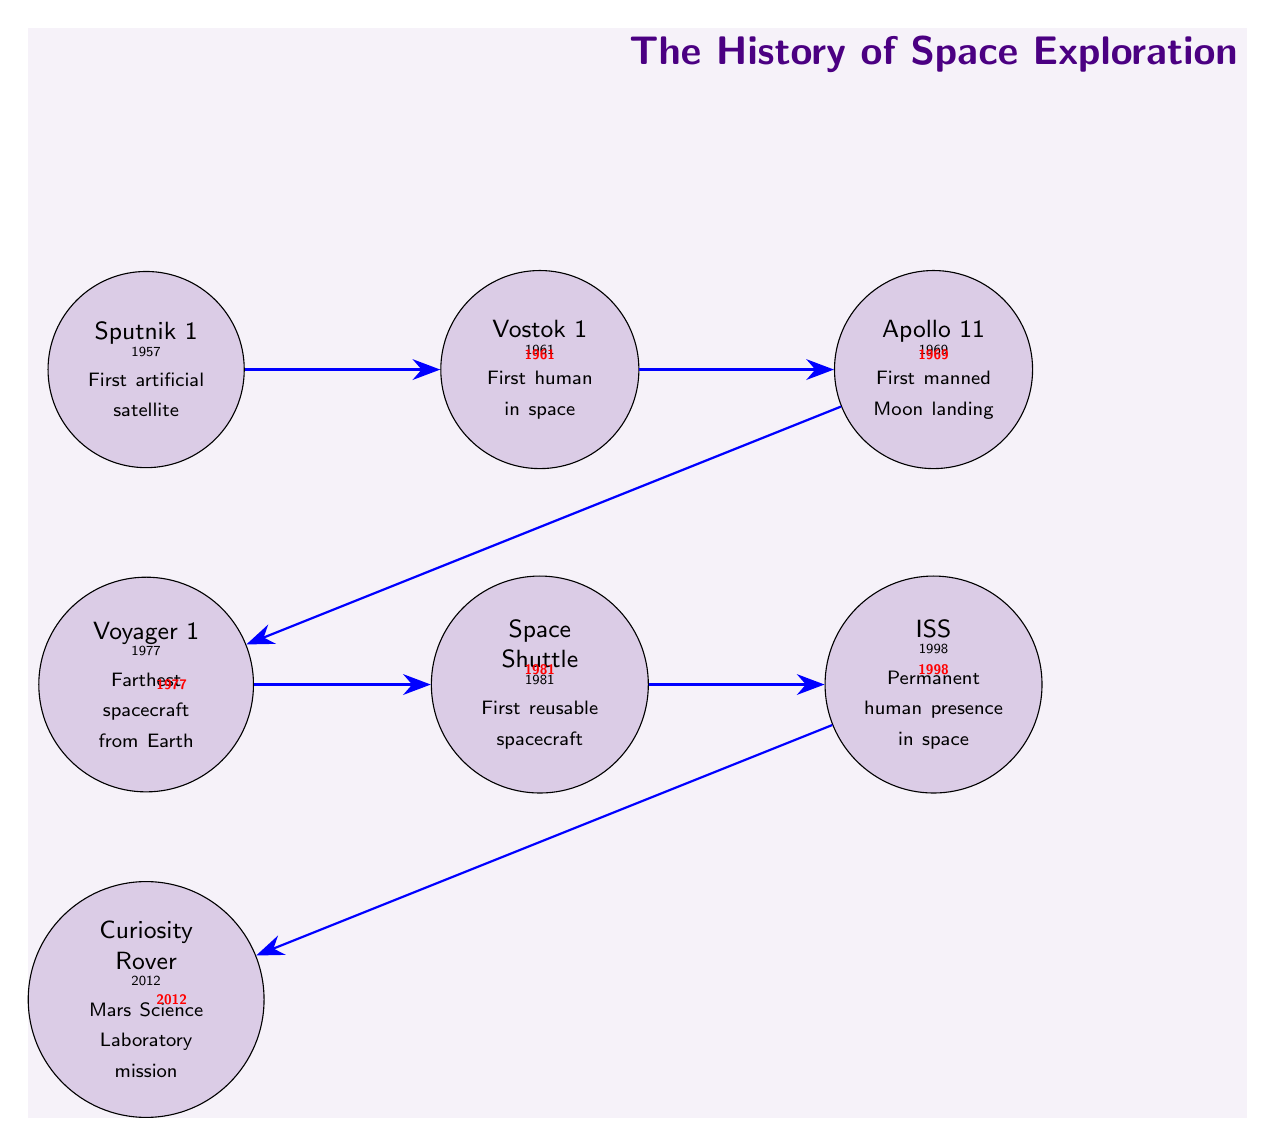What is the year of the first artificial satellite launch? The diagram indicates that the first artificial satellite, Sputnik 1, was launched in the year 1957. This can be directly seen next to the Sputnik node in the diagram.
Answer: 1957 Which event happened after the first human traveled to space? The first human in space, Vostok 1, occurred in 1961, after which Apollo 11, the first manned Moon landing, took place in 1969, as shown by the arrow connecting these two nodes.
Answer: Apollo 11 What is the farthest spacecraft from Earth? The diagram specifies that Voyager 1, launched in 1977, is the farthest spacecraft from Earth, as indicated in the respective node label.
Answer: Voyager 1 How many years were there between the first Moon landing and the launch of the Space Shuttle? The first manned Moon landing (Apollo 11) occurred in 1969 and the Space Shuttle launched in 1981. Thus, the difference is 1981 - 1969 = 12 years, straightforwardly calculated from the years provided in the diagram nodes.
Answer: 12 years What major milestone happened in 1998? According to the diagram, the International Space Station (ISS) was established in 1998, as noted in its corresponding node.
Answer: ISS Which event directly follows the Curiosity Rover in the timeline? The diagram shows that there are no events following the Curiosity Rover, which launched in 2012, as it is the last node in the sequence with no arrows leading to another event.
Answer: None Which two events are separated by the most years on the timeline? The first artificial satellite (Sputnik 1 in 1957) and the Curiosity Rover (2012) are separated by the most years. A simple calculation shows the difference of years: 2012 - 1957 = 55 years, making this the largest gap in the timeline.
Answer: 55 years What does the arrow between the Voyager 1 and Space Shuttle represent? The arrow between these two nodes signifies the chronological relationship where Voyager 1, launched in 1977, is followed by the launch of the Space Shuttle in 1981, indicating the sequence of events in space exploration history.
Answer: 1981 